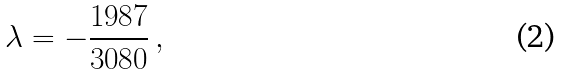<formula> <loc_0><loc_0><loc_500><loc_500>\lambda = - \frac { 1 9 8 7 } { 3 0 8 0 } \, ,</formula> 